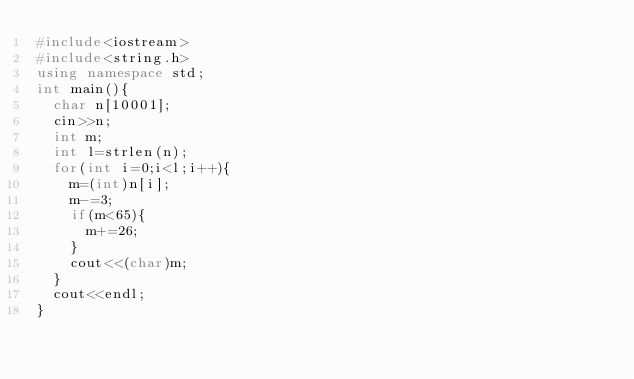<code> <loc_0><loc_0><loc_500><loc_500><_C++_>#include<iostream>
#include<string.h>
using namespace std;
int main(){
	char n[10001];
	cin>>n;
	int m;
	int l=strlen(n);
	for(int i=0;i<l;i++){
		m=(int)n[i];
		m-=3;
		if(m<65){
			m+=26;
		}
		cout<<(char)m;
	}
	cout<<endl;
}</code> 